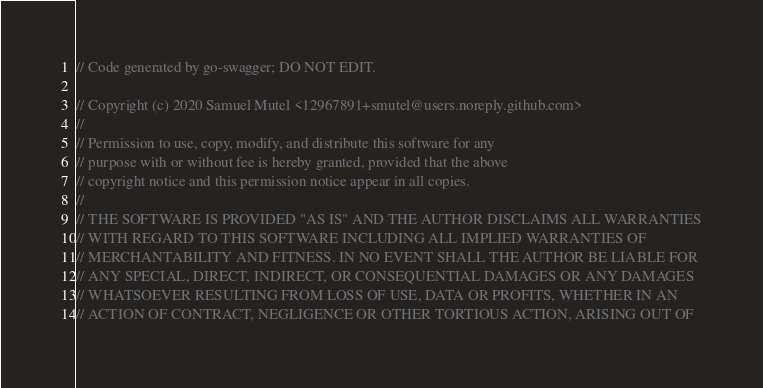Convert code to text. <code><loc_0><loc_0><loc_500><loc_500><_Go_>// Code generated by go-swagger; DO NOT EDIT.

// Copyright (c) 2020 Samuel Mutel <12967891+smutel@users.noreply.github.com>
//
// Permission to use, copy, modify, and distribute this software for any
// purpose with or without fee is hereby granted, provided that the above
// copyright notice and this permission notice appear in all copies.
//
// THE SOFTWARE IS PROVIDED "AS IS" AND THE AUTHOR DISCLAIMS ALL WARRANTIES
// WITH REGARD TO THIS SOFTWARE INCLUDING ALL IMPLIED WARRANTIES OF
// MERCHANTABILITY AND FITNESS. IN NO EVENT SHALL THE AUTHOR BE LIABLE FOR
// ANY SPECIAL, DIRECT, INDIRECT, OR CONSEQUENTIAL DAMAGES OR ANY DAMAGES
// WHATSOEVER RESULTING FROM LOSS OF USE, DATA OR PROFITS, WHETHER IN AN
// ACTION OF CONTRACT, NEGLIGENCE OR OTHER TORTIOUS ACTION, ARISING OUT OF</code> 